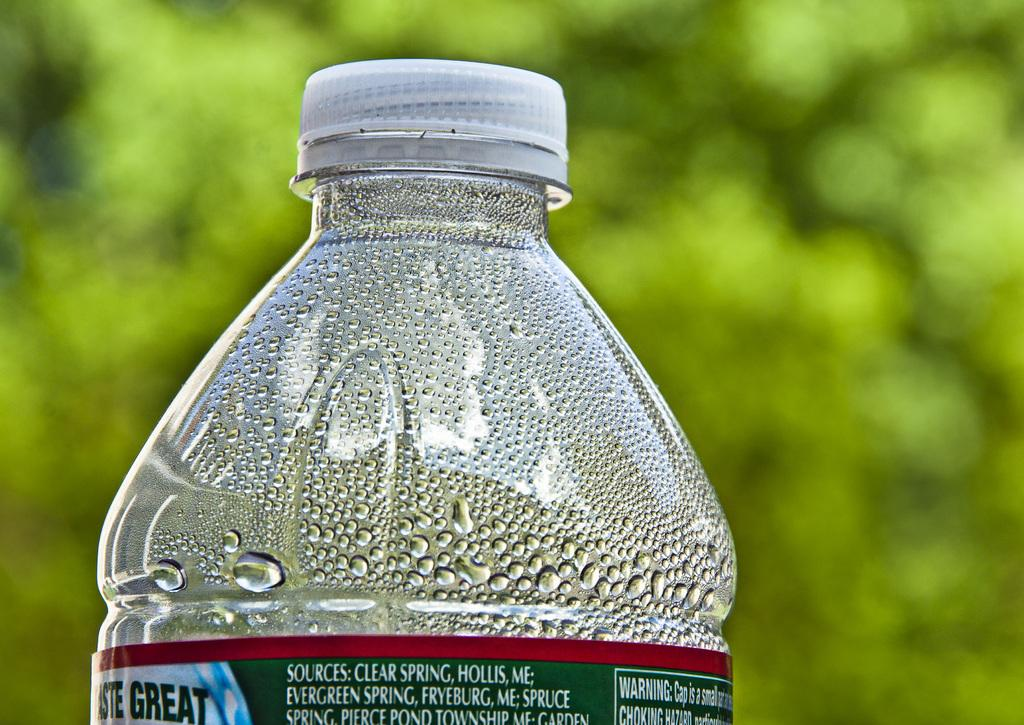<image>
Present a compact description of the photo's key features. The top of a water bottle that sources water from the Evergreen Spring. 